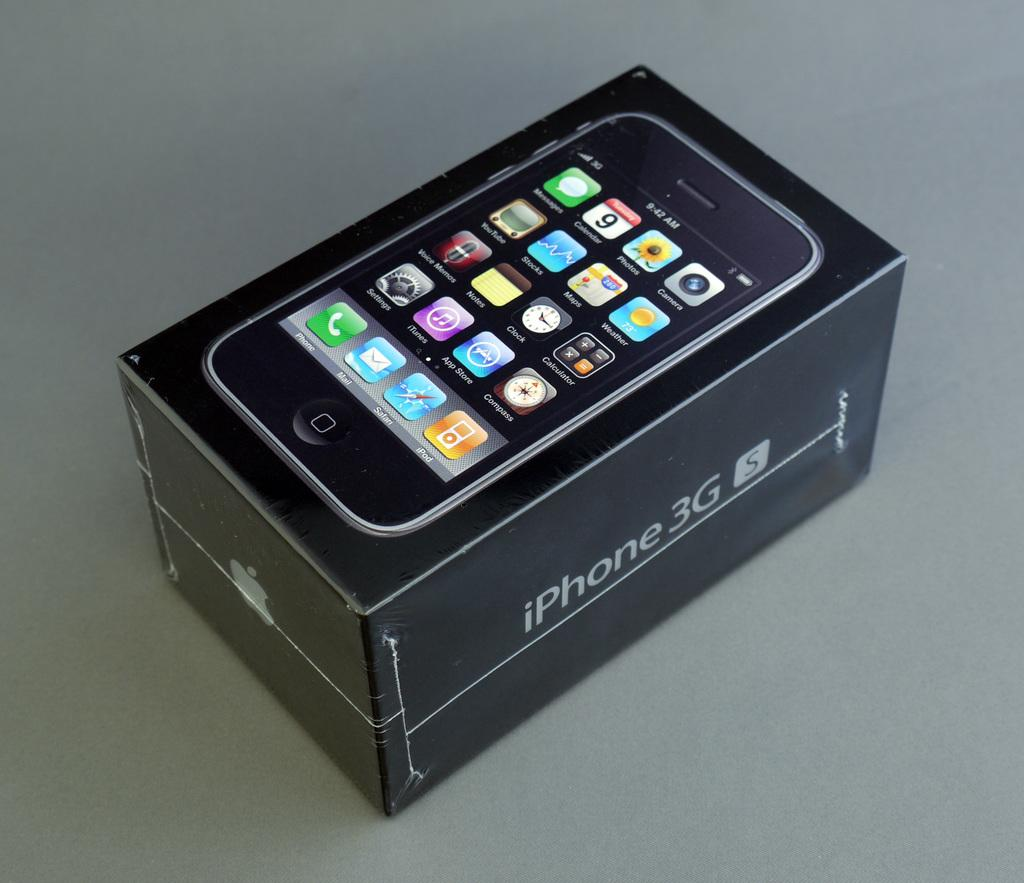Provide a one-sentence caption for the provided image. A phone sits on top of an iPhone 3G box. 